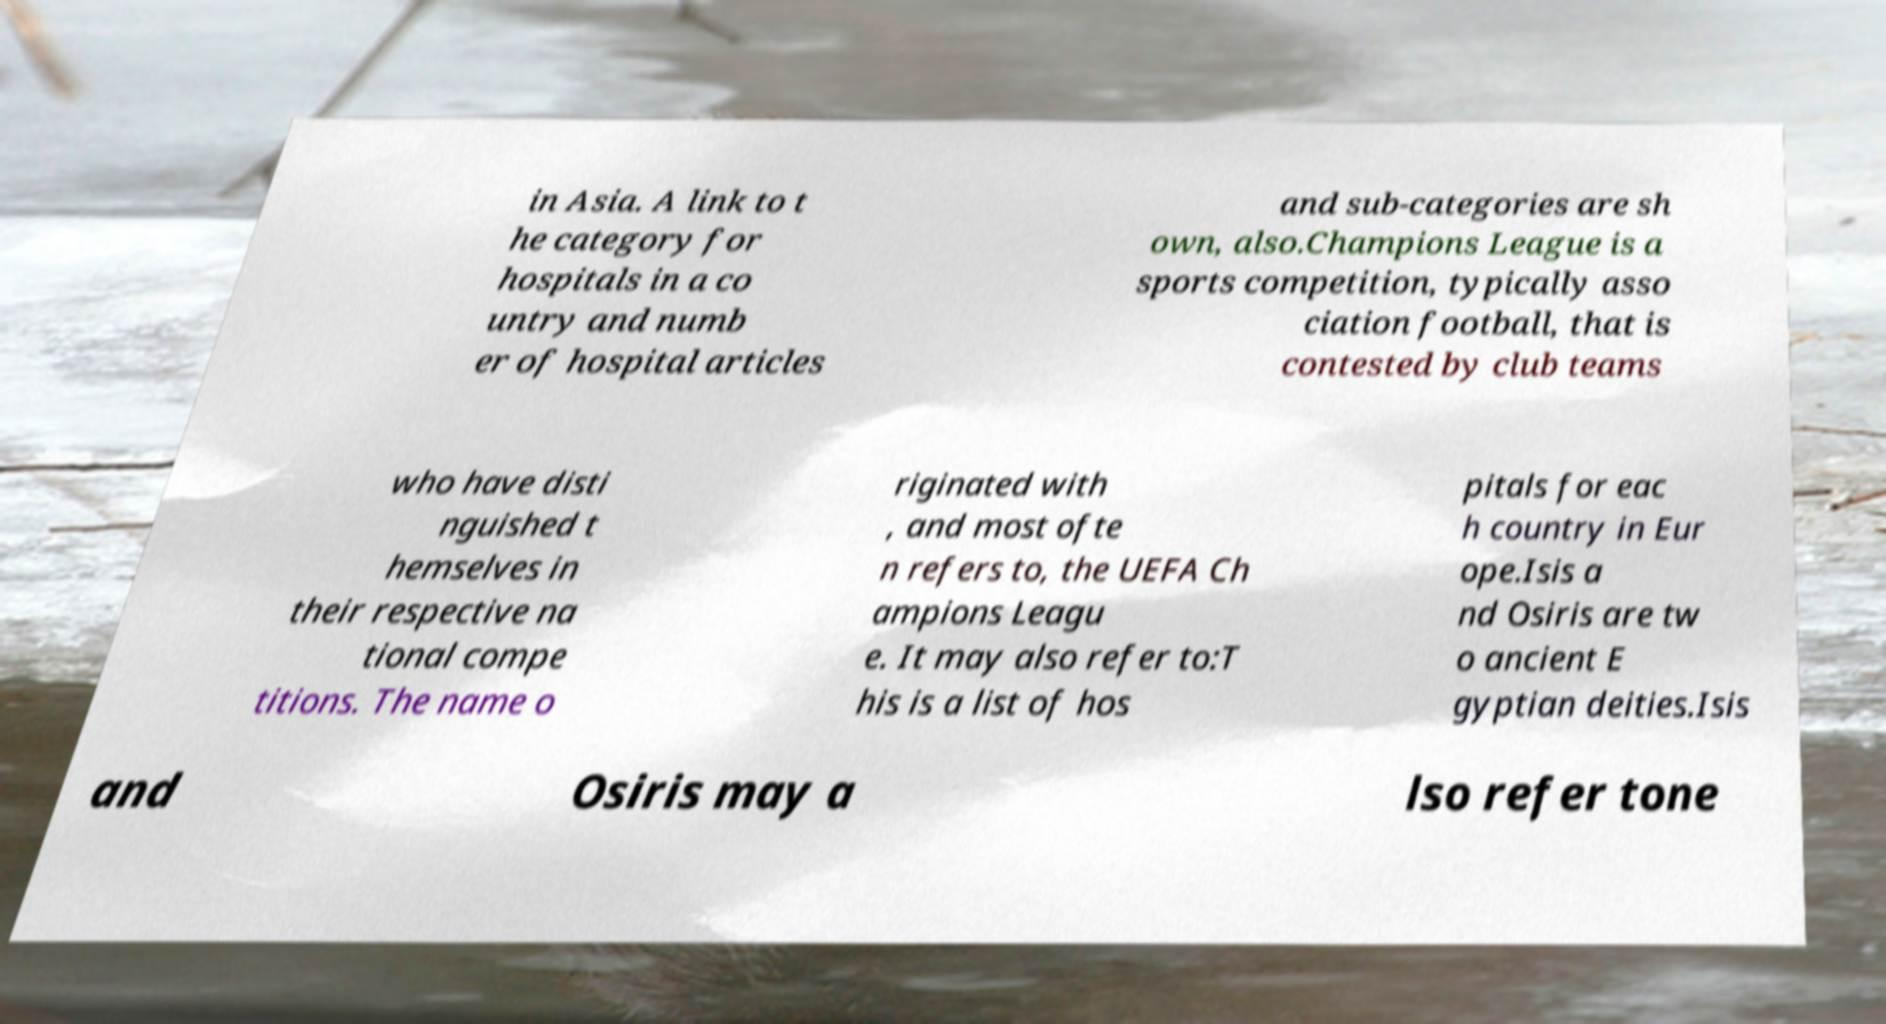Please read and relay the text visible in this image. What does it say? in Asia. A link to t he category for hospitals in a co untry and numb er of hospital articles and sub-categories are sh own, also.Champions League is a sports competition, typically asso ciation football, that is contested by club teams who have disti nguished t hemselves in their respective na tional compe titions. The name o riginated with , and most ofte n refers to, the UEFA Ch ampions Leagu e. It may also refer to:T his is a list of hos pitals for eac h country in Eur ope.Isis a nd Osiris are tw o ancient E gyptian deities.Isis and Osiris may a lso refer tone 